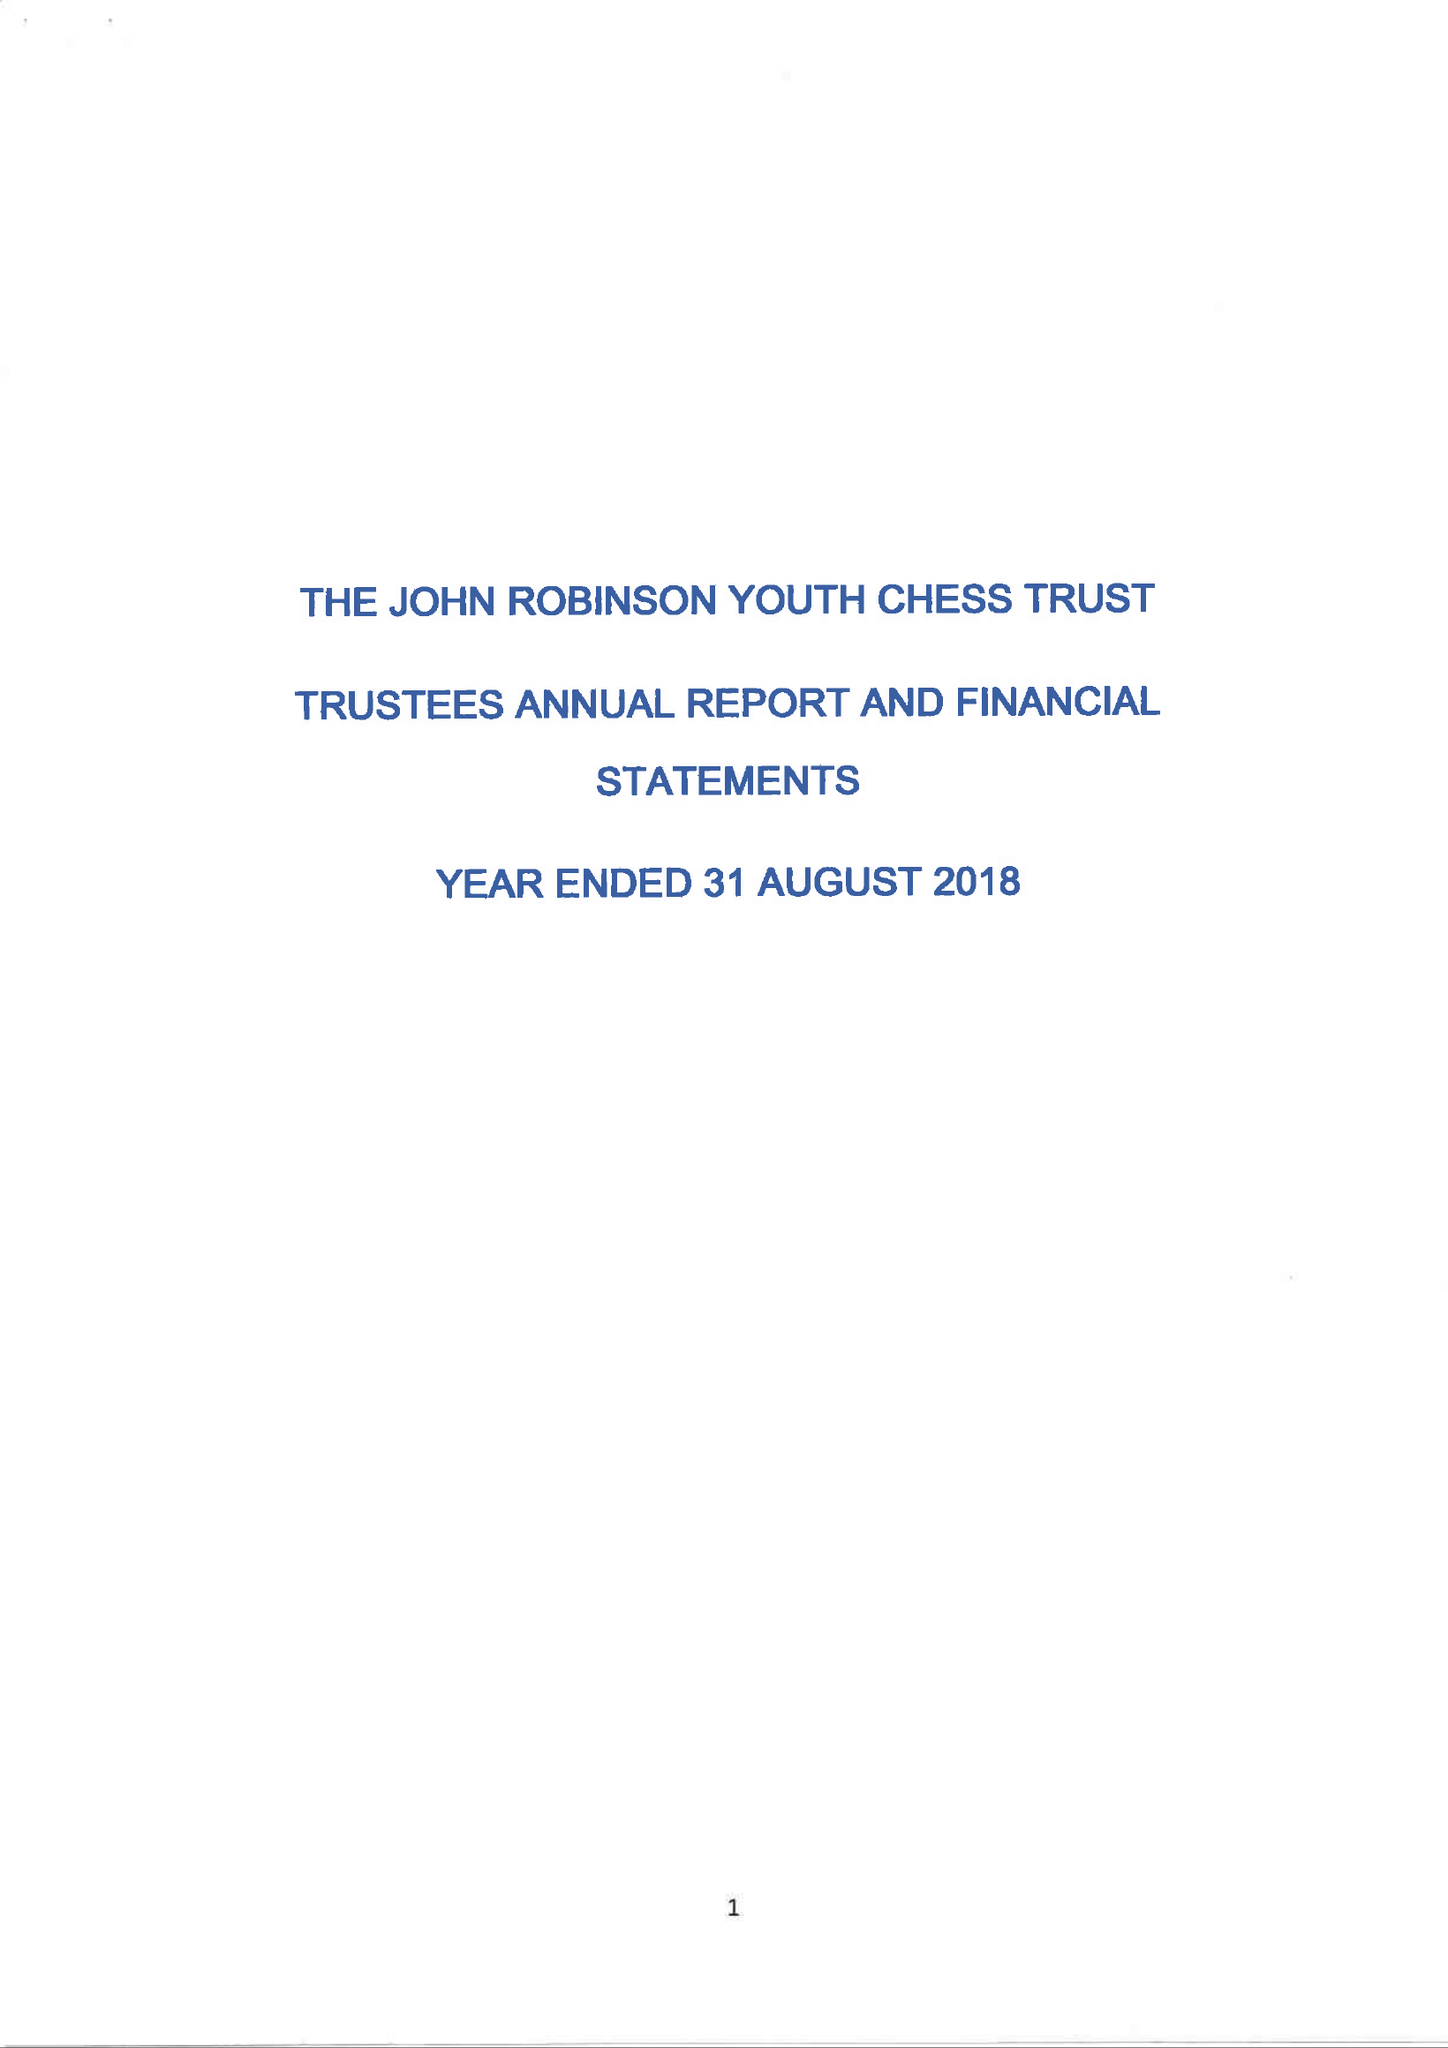What is the value for the report_date?
Answer the question using a single word or phrase. 2018-08-31 